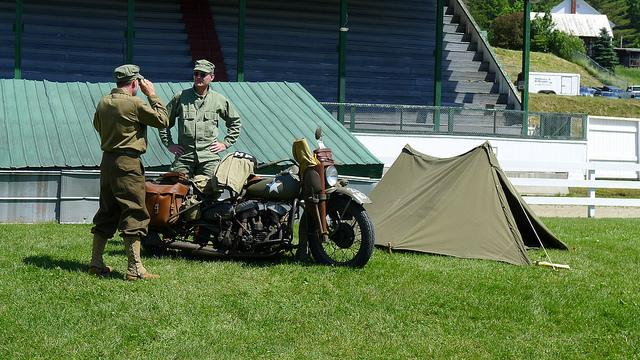Which one is the superior officer? facing camera 